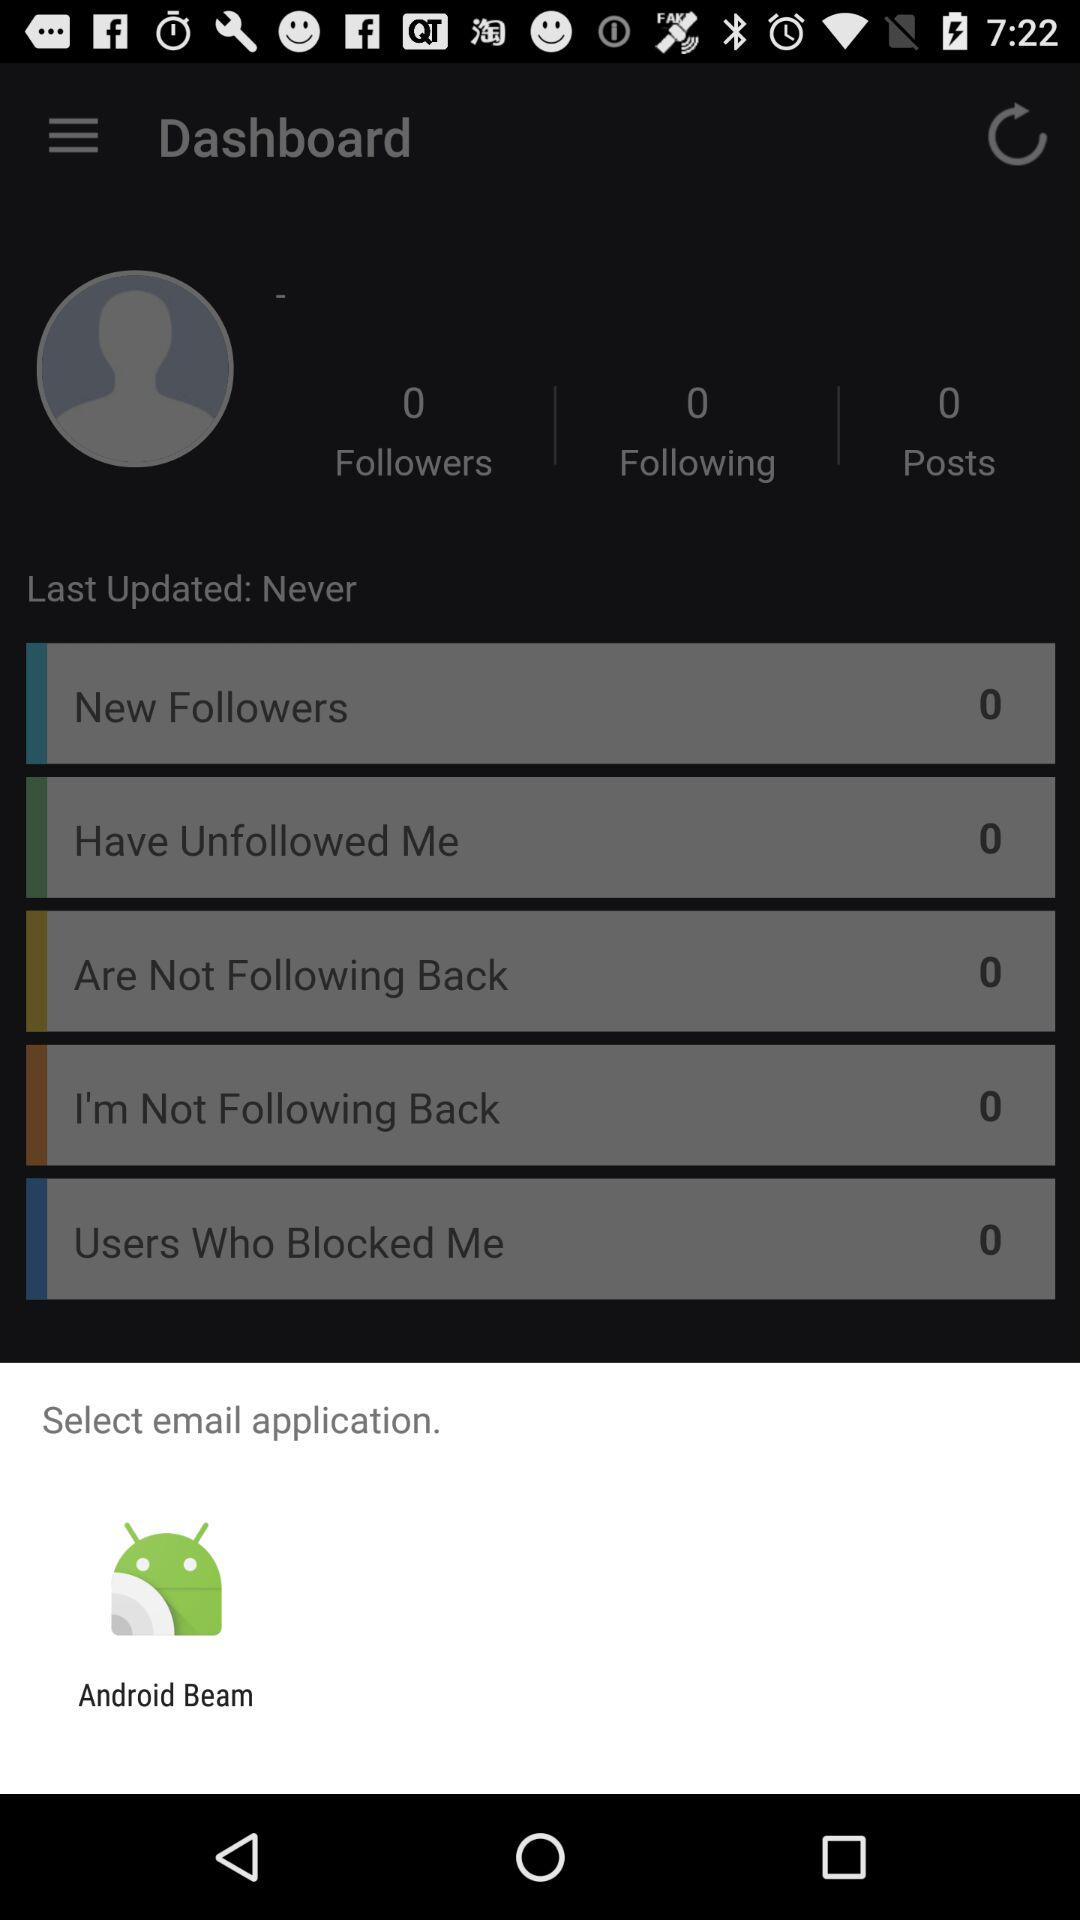What is the number of posts? The number of posts is 0. 